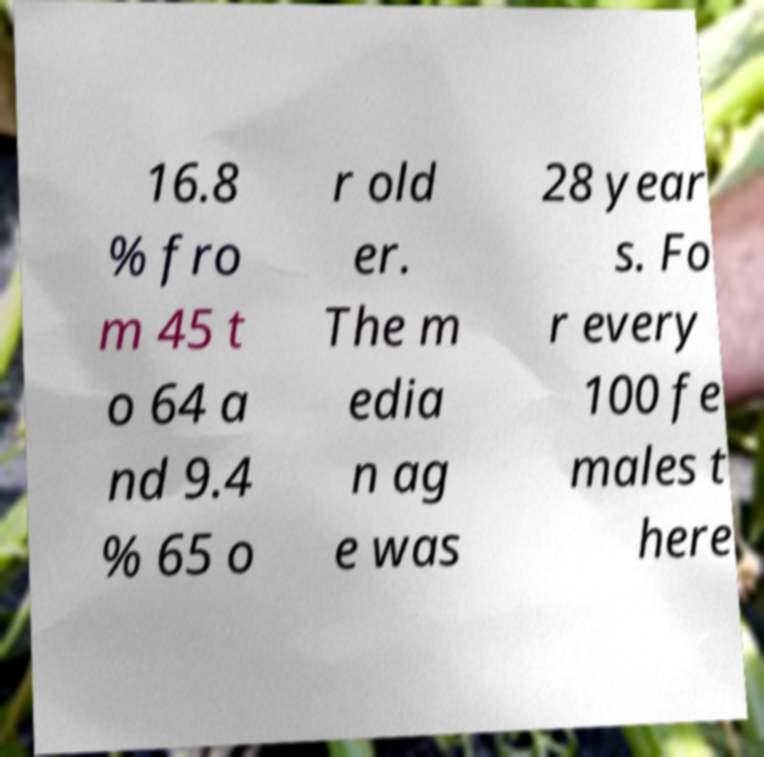I need the written content from this picture converted into text. Can you do that? 16.8 % fro m 45 t o 64 a nd 9.4 % 65 o r old er. The m edia n ag e was 28 year s. Fo r every 100 fe males t here 